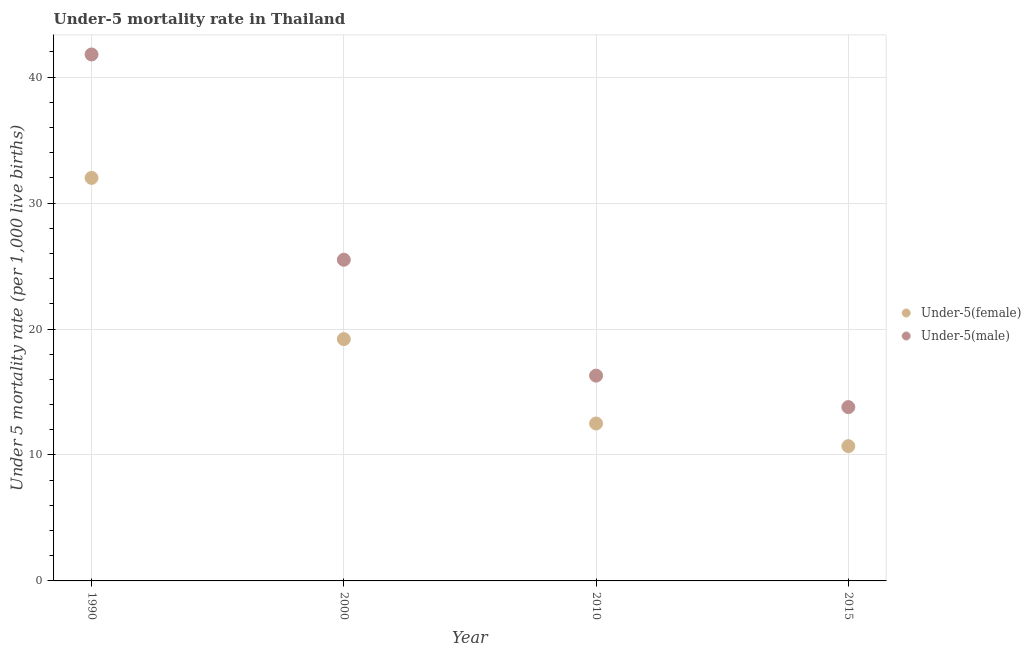What is the under-5 male mortality rate in 2000?
Give a very brief answer. 25.5. Across all years, what is the maximum under-5 female mortality rate?
Ensure brevity in your answer.  32. Across all years, what is the minimum under-5 male mortality rate?
Your response must be concise. 13.8. In which year was the under-5 female mortality rate maximum?
Make the answer very short. 1990. In which year was the under-5 female mortality rate minimum?
Provide a succinct answer. 2015. What is the total under-5 male mortality rate in the graph?
Offer a very short reply. 97.4. What is the difference between the under-5 female mortality rate in 1990 and that in 2000?
Make the answer very short. 12.8. What is the difference between the under-5 female mortality rate in 2010 and the under-5 male mortality rate in 1990?
Offer a terse response. -29.3. What is the average under-5 male mortality rate per year?
Provide a short and direct response. 24.35. In the year 1990, what is the difference between the under-5 male mortality rate and under-5 female mortality rate?
Offer a terse response. 9.8. In how many years, is the under-5 female mortality rate greater than 12?
Provide a short and direct response. 3. What is the ratio of the under-5 female mortality rate in 2000 to that in 2010?
Offer a terse response. 1.54. What is the difference between the highest and the second highest under-5 male mortality rate?
Offer a very short reply. 16.3. What is the difference between the highest and the lowest under-5 male mortality rate?
Provide a succinct answer. 28. In how many years, is the under-5 female mortality rate greater than the average under-5 female mortality rate taken over all years?
Provide a short and direct response. 2. Is the under-5 male mortality rate strictly less than the under-5 female mortality rate over the years?
Offer a terse response. No. How many dotlines are there?
Offer a terse response. 2. Does the graph contain grids?
Give a very brief answer. Yes. How many legend labels are there?
Provide a succinct answer. 2. What is the title of the graph?
Offer a terse response. Under-5 mortality rate in Thailand. Does "Domestic Liabilities" appear as one of the legend labels in the graph?
Your response must be concise. No. What is the label or title of the X-axis?
Make the answer very short. Year. What is the label or title of the Y-axis?
Ensure brevity in your answer.  Under 5 mortality rate (per 1,0 live births). What is the Under 5 mortality rate (per 1,000 live births) of Under-5(female) in 1990?
Provide a short and direct response. 32. What is the Under 5 mortality rate (per 1,000 live births) in Under-5(male) in 1990?
Offer a terse response. 41.8. What is the Under 5 mortality rate (per 1,000 live births) of Under-5(female) in 2000?
Give a very brief answer. 19.2. What is the Under 5 mortality rate (per 1,000 live births) in Under-5(male) in 2000?
Provide a short and direct response. 25.5. What is the Under 5 mortality rate (per 1,000 live births) of Under-5(female) in 2015?
Your answer should be very brief. 10.7. What is the Under 5 mortality rate (per 1,000 live births) of Under-5(male) in 2015?
Make the answer very short. 13.8. Across all years, what is the maximum Under 5 mortality rate (per 1,000 live births) in Under-5(female)?
Offer a terse response. 32. Across all years, what is the maximum Under 5 mortality rate (per 1,000 live births) of Under-5(male)?
Offer a terse response. 41.8. What is the total Under 5 mortality rate (per 1,000 live births) in Under-5(female) in the graph?
Provide a succinct answer. 74.4. What is the total Under 5 mortality rate (per 1,000 live births) in Under-5(male) in the graph?
Ensure brevity in your answer.  97.4. What is the difference between the Under 5 mortality rate (per 1,000 live births) in Under-5(female) in 1990 and that in 2010?
Your answer should be compact. 19.5. What is the difference between the Under 5 mortality rate (per 1,000 live births) in Under-5(male) in 1990 and that in 2010?
Provide a succinct answer. 25.5. What is the difference between the Under 5 mortality rate (per 1,000 live births) of Under-5(female) in 1990 and that in 2015?
Ensure brevity in your answer.  21.3. What is the difference between the Under 5 mortality rate (per 1,000 live births) of Under-5(male) in 1990 and that in 2015?
Give a very brief answer. 28. What is the difference between the Under 5 mortality rate (per 1,000 live births) in Under-5(female) in 2000 and that in 2015?
Give a very brief answer. 8.5. What is the difference between the Under 5 mortality rate (per 1,000 live births) in Under-5(male) in 2000 and that in 2015?
Your response must be concise. 11.7. What is the difference between the Under 5 mortality rate (per 1,000 live births) of Under-5(female) in 2010 and that in 2015?
Your response must be concise. 1.8. What is the difference between the Under 5 mortality rate (per 1,000 live births) in Under-5(female) in 2000 and the Under 5 mortality rate (per 1,000 live births) in Under-5(male) in 2010?
Ensure brevity in your answer.  2.9. What is the difference between the Under 5 mortality rate (per 1,000 live births) in Under-5(female) in 2010 and the Under 5 mortality rate (per 1,000 live births) in Under-5(male) in 2015?
Your response must be concise. -1.3. What is the average Under 5 mortality rate (per 1,000 live births) of Under-5(male) per year?
Your answer should be compact. 24.35. In the year 2000, what is the difference between the Under 5 mortality rate (per 1,000 live births) in Under-5(female) and Under 5 mortality rate (per 1,000 live births) in Under-5(male)?
Provide a short and direct response. -6.3. In the year 2010, what is the difference between the Under 5 mortality rate (per 1,000 live births) in Under-5(female) and Under 5 mortality rate (per 1,000 live births) in Under-5(male)?
Keep it short and to the point. -3.8. What is the ratio of the Under 5 mortality rate (per 1,000 live births) of Under-5(male) in 1990 to that in 2000?
Your response must be concise. 1.64. What is the ratio of the Under 5 mortality rate (per 1,000 live births) of Under-5(female) in 1990 to that in 2010?
Provide a short and direct response. 2.56. What is the ratio of the Under 5 mortality rate (per 1,000 live births) in Under-5(male) in 1990 to that in 2010?
Your response must be concise. 2.56. What is the ratio of the Under 5 mortality rate (per 1,000 live births) of Under-5(female) in 1990 to that in 2015?
Provide a short and direct response. 2.99. What is the ratio of the Under 5 mortality rate (per 1,000 live births) of Under-5(male) in 1990 to that in 2015?
Offer a terse response. 3.03. What is the ratio of the Under 5 mortality rate (per 1,000 live births) in Under-5(female) in 2000 to that in 2010?
Provide a short and direct response. 1.54. What is the ratio of the Under 5 mortality rate (per 1,000 live births) of Under-5(male) in 2000 to that in 2010?
Your answer should be compact. 1.56. What is the ratio of the Under 5 mortality rate (per 1,000 live births) of Under-5(female) in 2000 to that in 2015?
Provide a succinct answer. 1.79. What is the ratio of the Under 5 mortality rate (per 1,000 live births) of Under-5(male) in 2000 to that in 2015?
Ensure brevity in your answer.  1.85. What is the ratio of the Under 5 mortality rate (per 1,000 live births) of Under-5(female) in 2010 to that in 2015?
Offer a terse response. 1.17. What is the ratio of the Under 5 mortality rate (per 1,000 live births) in Under-5(male) in 2010 to that in 2015?
Make the answer very short. 1.18. What is the difference between the highest and the second highest Under 5 mortality rate (per 1,000 live births) of Under-5(male)?
Make the answer very short. 16.3. What is the difference between the highest and the lowest Under 5 mortality rate (per 1,000 live births) in Under-5(female)?
Ensure brevity in your answer.  21.3. What is the difference between the highest and the lowest Under 5 mortality rate (per 1,000 live births) in Under-5(male)?
Provide a succinct answer. 28. 